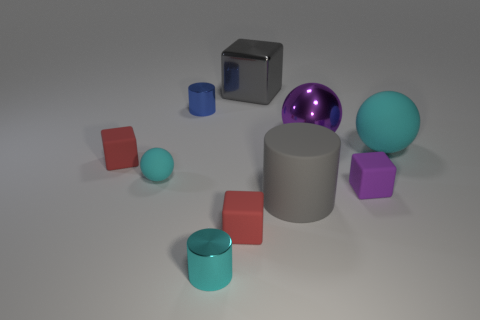Subtract all purple blocks. How many blocks are left? 3 Subtract all brown balls. How many red blocks are left? 2 Subtract 2 blocks. How many blocks are left? 2 Subtract all gray cylinders. How many cylinders are left? 2 Subtract all yellow balls. Subtract all red cubes. How many balls are left? 3 Subtract 0 brown cubes. How many objects are left? 10 Subtract all cylinders. How many objects are left? 7 Subtract all small yellow matte cylinders. Subtract all big gray cylinders. How many objects are left? 9 Add 5 small blue metallic cylinders. How many small blue metallic cylinders are left? 6 Add 3 small brown rubber blocks. How many small brown rubber blocks exist? 3 